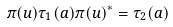<formula> <loc_0><loc_0><loc_500><loc_500>\pi ( u ) \tau _ { 1 } ( a ) \pi ( u ) ^ { * } = \tau _ { 2 } ( a )</formula> 